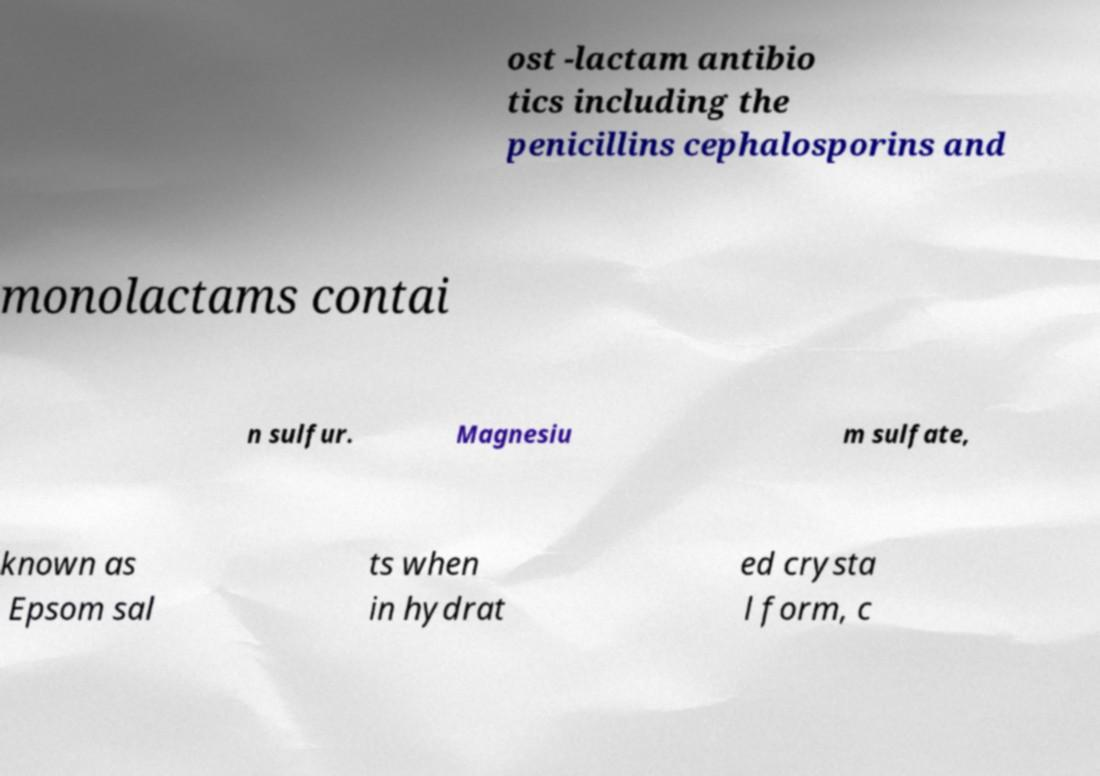Can you accurately transcribe the text from the provided image for me? ost -lactam antibio tics including the penicillins cephalosporins and monolactams contai n sulfur. Magnesiu m sulfate, known as Epsom sal ts when in hydrat ed crysta l form, c 